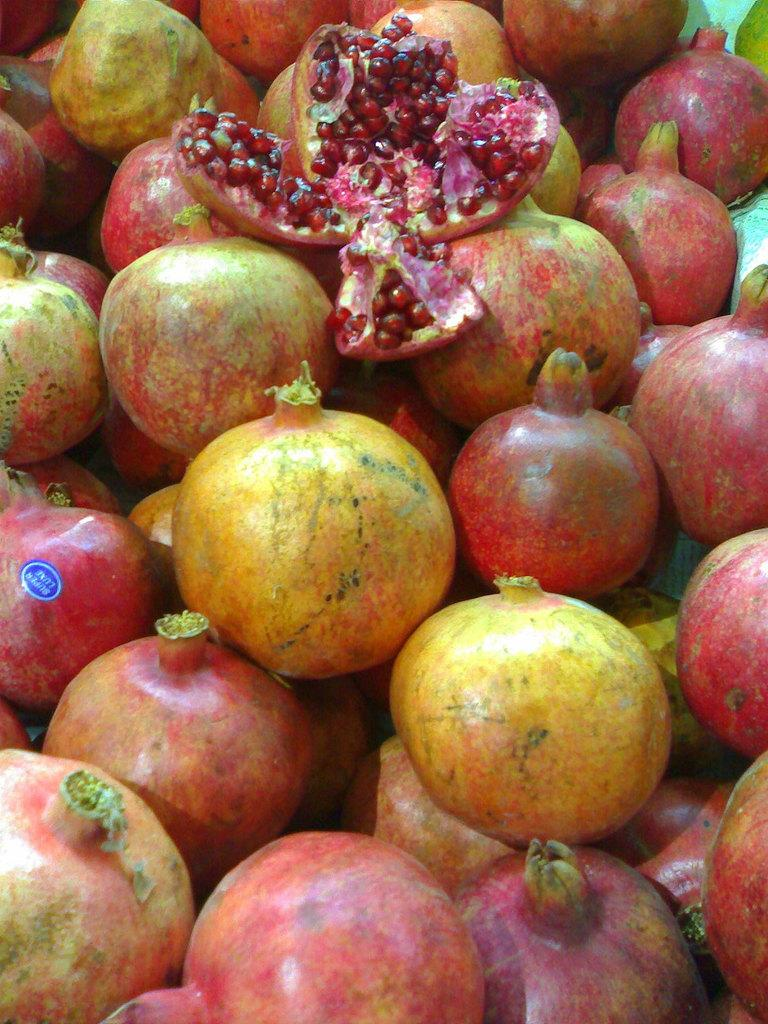What type of fruit is featured in the image? There are many pomegranates in the image. What color are the pomegranates? The pomegranates are red in color. Can you tell me how many owls are sitting on the pomegranates in the image? There are no owls present in the image; it features only pomegranates. 